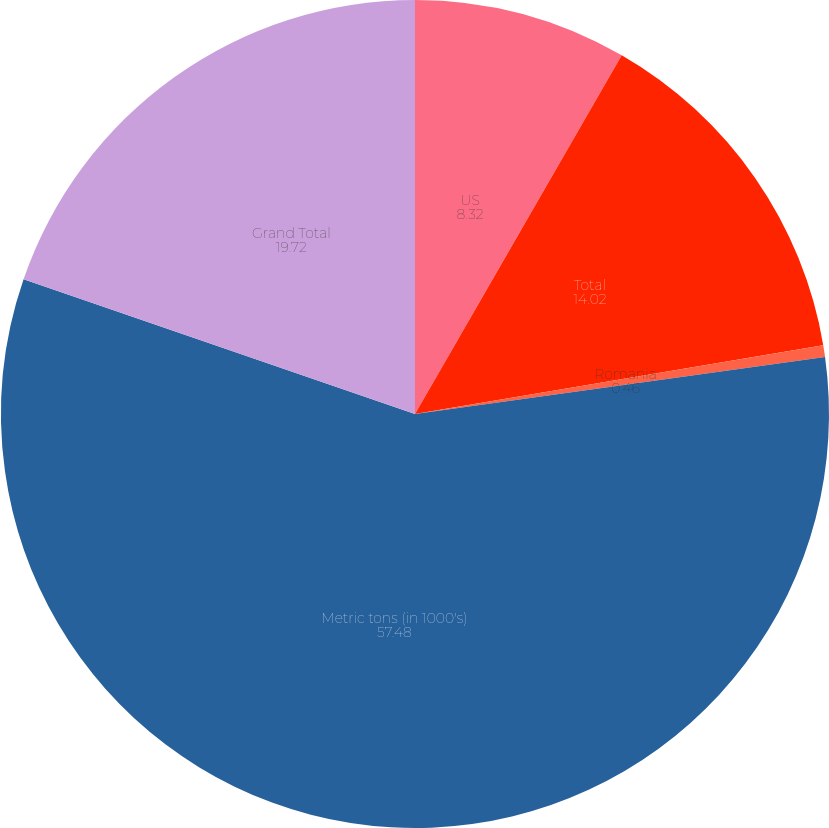Convert chart. <chart><loc_0><loc_0><loc_500><loc_500><pie_chart><fcel>US<fcel>Total<fcel>Romania<fcel>Metric tons (in 1000's)<fcel>Grand Total<nl><fcel>8.32%<fcel>14.02%<fcel>0.46%<fcel>57.48%<fcel>19.72%<nl></chart> 